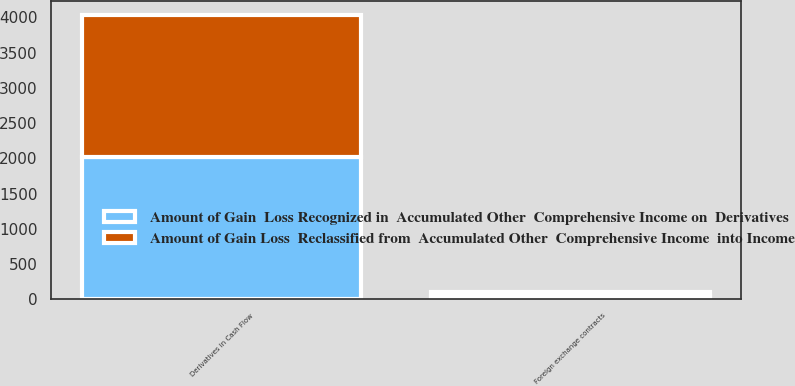<chart> <loc_0><loc_0><loc_500><loc_500><stacked_bar_chart><ecel><fcel>Derivatives in Cash Flow<fcel>Foreign exchange contracts<nl><fcel>Amount of Gain  Loss Recognized in  Accumulated Other  Comprehensive Income on  Derivatives<fcel>2016<fcel>48<nl><fcel>Amount of Gain Loss  Reclassified from  Accumulated Other  Comprehensive Income  into Income<fcel>2016<fcel>51<nl></chart> 